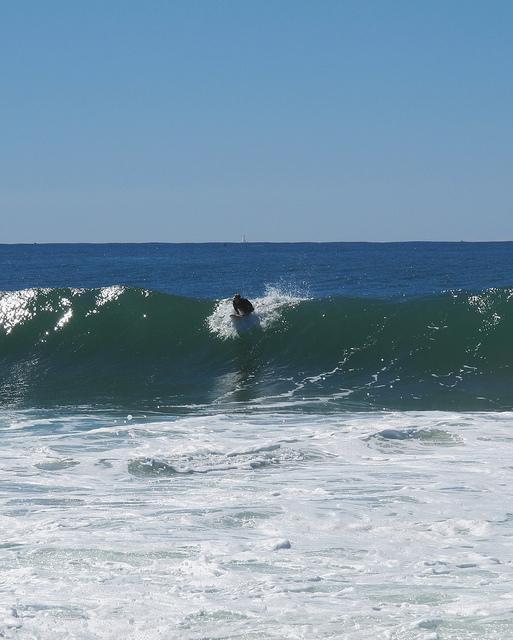How many waves are cresting?
Give a very brief answer. 1. How many people are in the water?
Give a very brief answer. 1. 